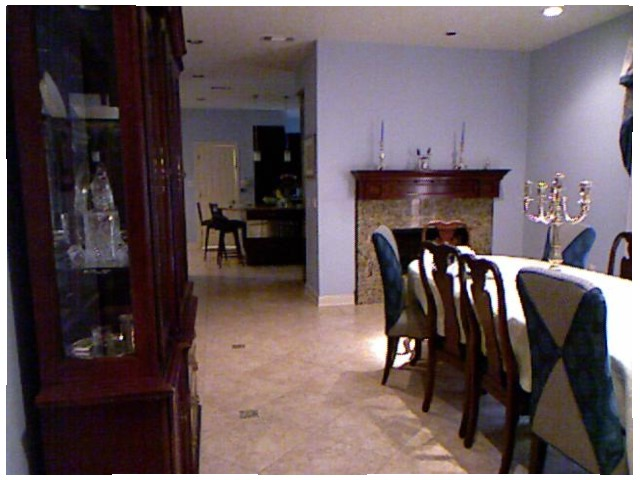<image>
Is there a candle on the wall? No. The candle is not positioned on the wall. They may be near each other, but the candle is not supported by or resting on top of the wall. Where is the chair in relation to the table? Is it on the table? No. The chair is not positioned on the table. They may be near each other, but the chair is not supported by or resting on top of the table. Is there a chair to the left of the chair? No. The chair is not to the left of the chair. From this viewpoint, they have a different horizontal relationship. Is there a chair behind the dining table? No. The chair is not behind the dining table. From this viewpoint, the chair appears to be positioned elsewhere in the scene. 